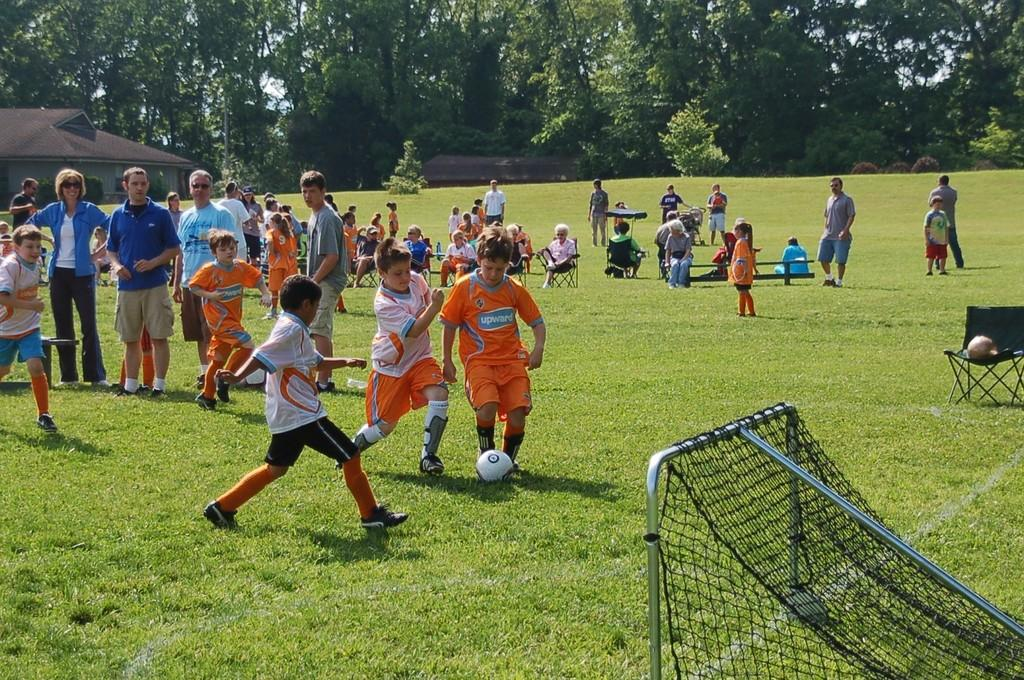What is happening in the image involving the group of persons? The persons in the image are sitting and playing. What can be seen on the right side of the image? There is a net on the right side of the image. What is visible in the background of the image? There are trees in the background of the image. What type of caption is written on the net in the image? There is no caption written on the net in the image; it is simply a net used for playing. 